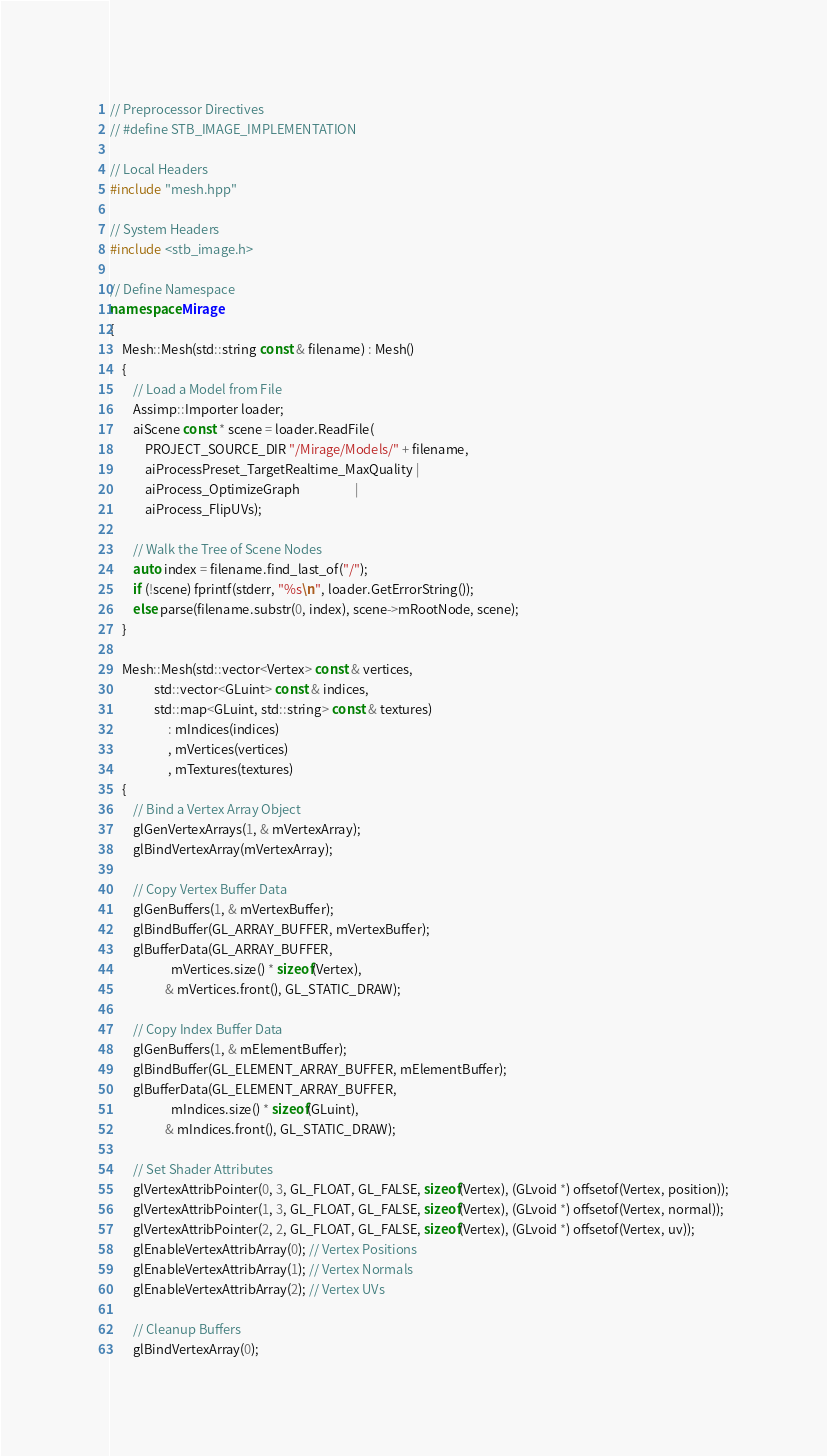Convert code to text. <code><loc_0><loc_0><loc_500><loc_500><_C++_>// Preprocessor Directives
// #define STB_IMAGE_IMPLEMENTATION

// Local Headers
#include "mesh.hpp"

// System Headers
#include <stb_image.h>

// Define Namespace
namespace Mirage
{
    Mesh::Mesh(std::string const & filename) : Mesh()
    {
        // Load a Model from File
        Assimp::Importer loader;
        aiScene const * scene = loader.ReadFile(
            PROJECT_SOURCE_DIR "/Mirage/Models/" + filename,
            aiProcessPreset_TargetRealtime_MaxQuality |
            aiProcess_OptimizeGraph                   |
            aiProcess_FlipUVs);

        // Walk the Tree of Scene Nodes
        auto index = filename.find_last_of("/");
        if (!scene) fprintf(stderr, "%s\n", loader.GetErrorString());
        else parse(filename.substr(0, index), scene->mRootNode, scene);
    }

    Mesh::Mesh(std::vector<Vertex> const & vertices,
               std::vector<GLuint> const & indices,
               std::map<GLuint, std::string> const & textures)
                    : mIndices(indices)
                    , mVertices(vertices)
                    , mTextures(textures)
    {
        // Bind a Vertex Array Object
        glGenVertexArrays(1, & mVertexArray);
        glBindVertexArray(mVertexArray);

        // Copy Vertex Buffer Data
        glGenBuffers(1, & mVertexBuffer);
        glBindBuffer(GL_ARRAY_BUFFER, mVertexBuffer);
        glBufferData(GL_ARRAY_BUFFER,
                     mVertices.size() * sizeof(Vertex),
                   & mVertices.front(), GL_STATIC_DRAW);

        // Copy Index Buffer Data
        glGenBuffers(1, & mElementBuffer);
        glBindBuffer(GL_ELEMENT_ARRAY_BUFFER, mElementBuffer);
        glBufferData(GL_ELEMENT_ARRAY_BUFFER,
                     mIndices.size() * sizeof(GLuint),
                   & mIndices.front(), GL_STATIC_DRAW);

        // Set Shader Attributes
        glVertexAttribPointer(0, 3, GL_FLOAT, GL_FALSE, sizeof(Vertex), (GLvoid *) offsetof(Vertex, position));
        glVertexAttribPointer(1, 3, GL_FLOAT, GL_FALSE, sizeof(Vertex), (GLvoid *) offsetof(Vertex, normal));
        glVertexAttribPointer(2, 2, GL_FLOAT, GL_FALSE, sizeof(Vertex), (GLvoid *) offsetof(Vertex, uv));
        glEnableVertexAttribArray(0); // Vertex Positions
        glEnableVertexAttribArray(1); // Vertex Normals
        glEnableVertexAttribArray(2); // Vertex UVs

        // Cleanup Buffers
        glBindVertexArray(0);</code> 